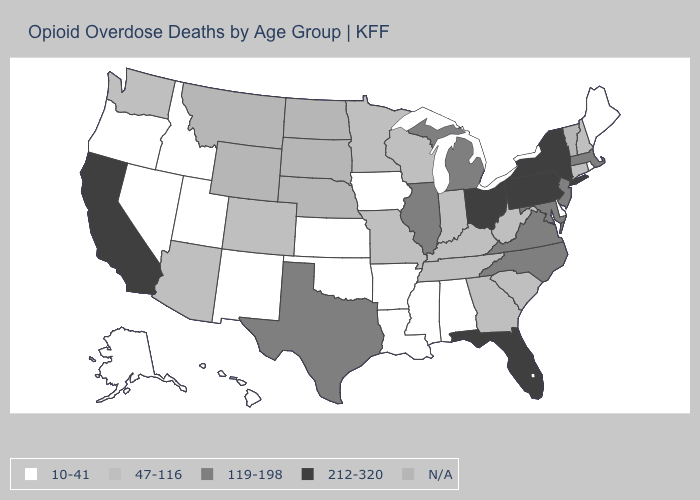Name the states that have a value in the range 119-198?
Answer briefly. Illinois, Maryland, Massachusetts, Michigan, New Jersey, North Carolina, Texas, Virginia. Which states have the highest value in the USA?
Write a very short answer. California, Florida, New York, Ohio, Pennsylvania. What is the value of Arizona?
Be succinct. 47-116. What is the value of Colorado?
Give a very brief answer. 47-116. What is the lowest value in the USA?
Quick response, please. 10-41. Does the first symbol in the legend represent the smallest category?
Quick response, please. Yes. Does Florida have the highest value in the South?
Answer briefly. Yes. What is the highest value in states that border South Dakota?
Answer briefly. 47-116. Does the first symbol in the legend represent the smallest category?
Give a very brief answer. Yes. What is the value of Alaska?
Keep it brief. 10-41. Does Iowa have the highest value in the USA?
Keep it brief. No. What is the value of Massachusetts?
Write a very short answer. 119-198. What is the value of Wyoming?
Be succinct. N/A. 